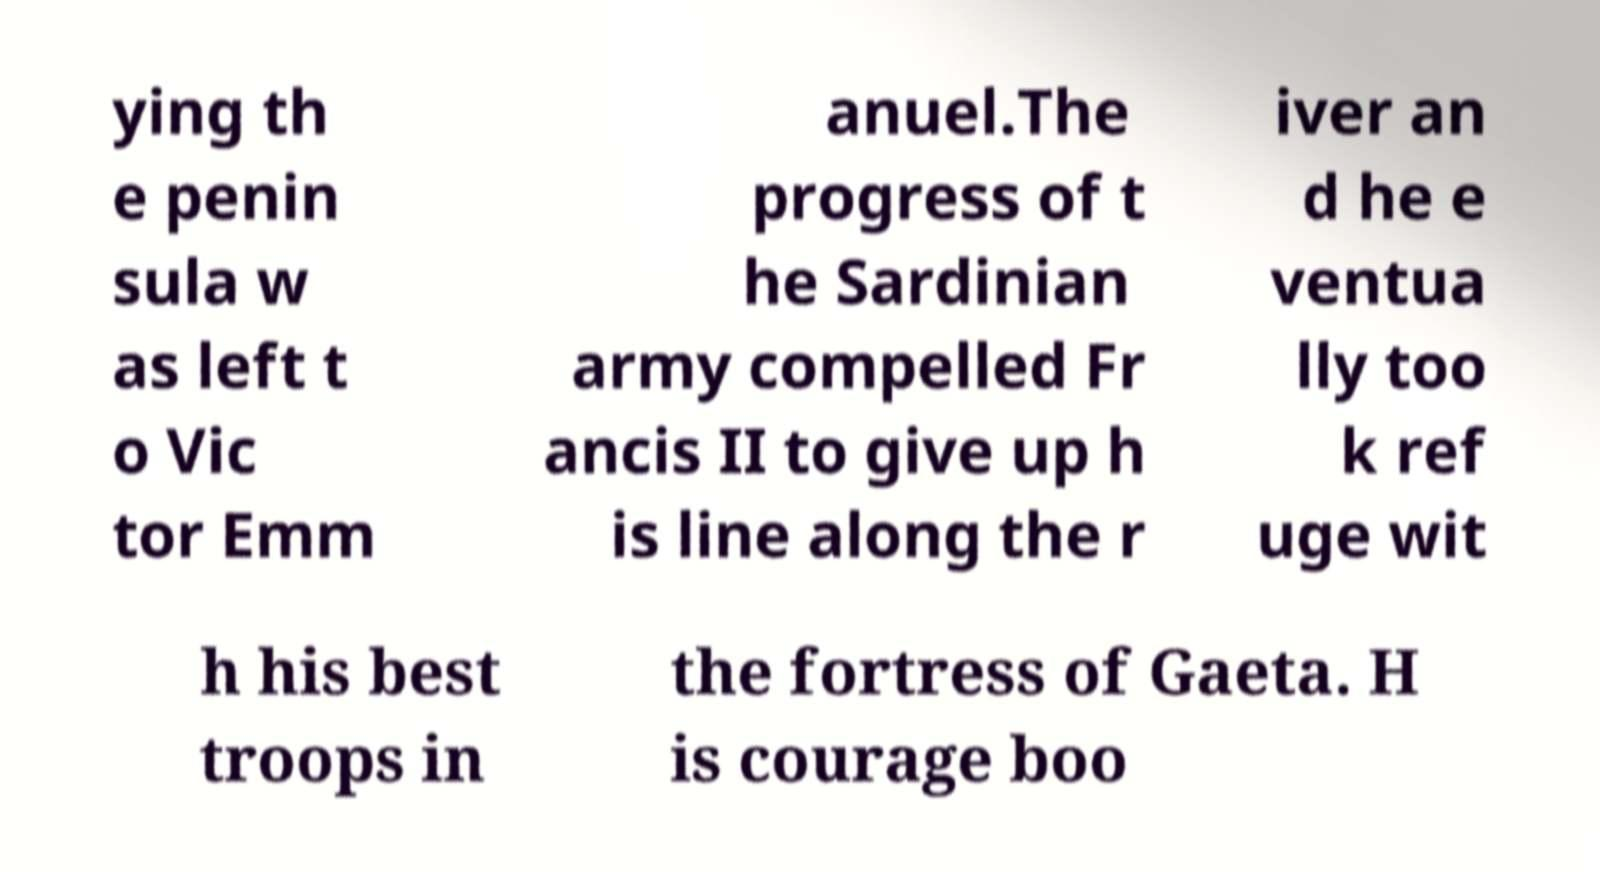What messages or text are displayed in this image? I need them in a readable, typed format. ying th e penin sula w as left t o Vic tor Emm anuel.The progress of t he Sardinian army compelled Fr ancis II to give up h is line along the r iver an d he e ventua lly too k ref uge wit h his best troops in the fortress of Gaeta. H is courage boo 